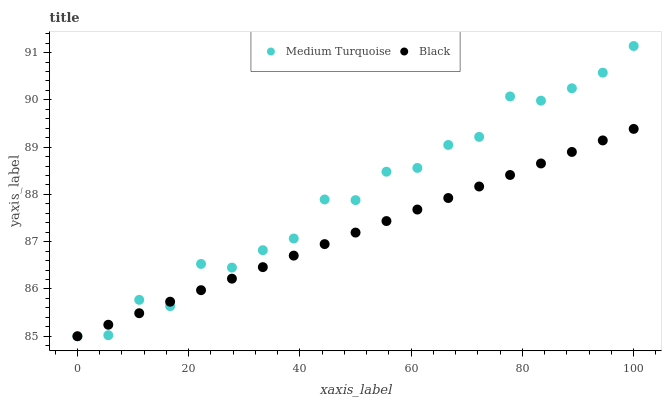Does Black have the minimum area under the curve?
Answer yes or no. Yes. Does Medium Turquoise have the maximum area under the curve?
Answer yes or no. Yes. Does Medium Turquoise have the minimum area under the curve?
Answer yes or no. No. Is Black the smoothest?
Answer yes or no. Yes. Is Medium Turquoise the roughest?
Answer yes or no. Yes. Is Medium Turquoise the smoothest?
Answer yes or no. No. Does Black have the lowest value?
Answer yes or no. Yes. Does Medium Turquoise have the highest value?
Answer yes or no. Yes. Does Medium Turquoise intersect Black?
Answer yes or no. Yes. Is Medium Turquoise less than Black?
Answer yes or no. No. Is Medium Turquoise greater than Black?
Answer yes or no. No. 